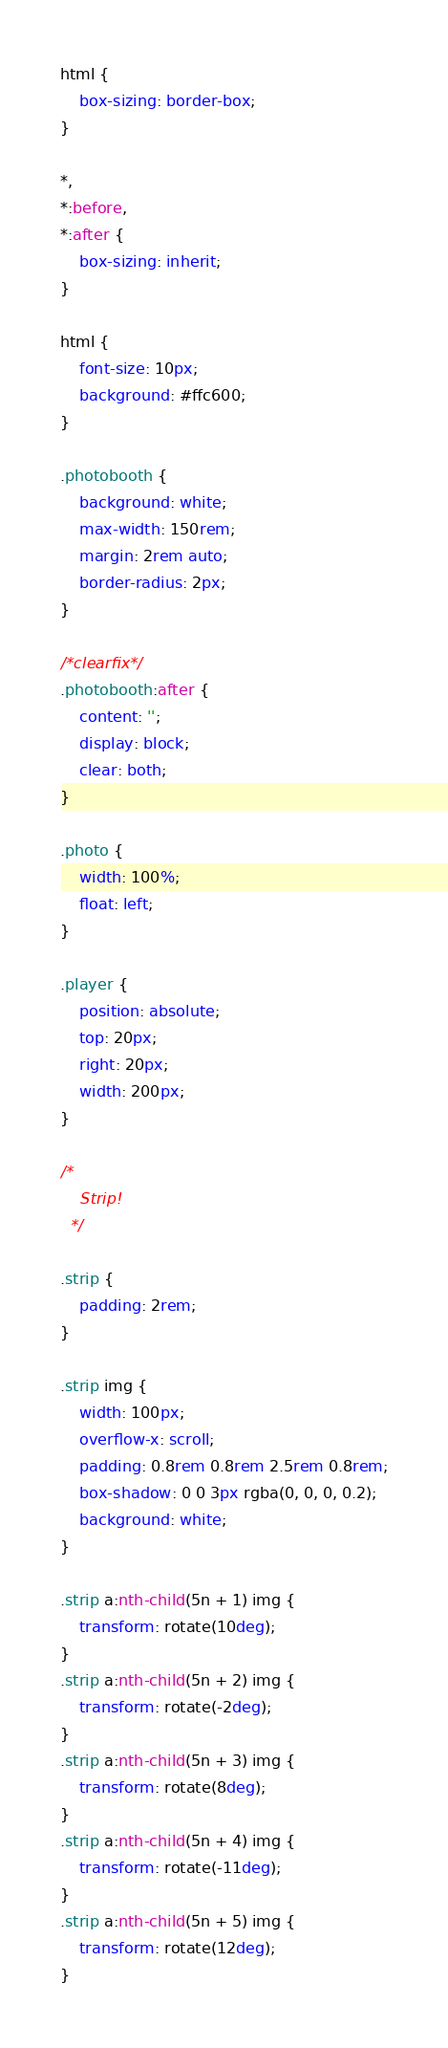<code> <loc_0><loc_0><loc_500><loc_500><_CSS_>html {
    box-sizing: border-box;
}

*,
*:before,
*:after {
    box-sizing: inherit;
}

html {
    font-size: 10px;
    background: #ffc600;
}

.photobooth {
    background: white;
    max-width: 150rem;
    margin: 2rem auto;
    border-radius: 2px;
}

/*clearfix*/
.photobooth:after {
    content: '';
    display: block;
    clear: both;
}

.photo {
    width: 100%;
    float: left;
}

.player {
    position: absolute;
    top: 20px;
    right: 20px;
    width: 200px;
}

/*
    Strip!
  */

.strip {
    padding: 2rem;
}

.strip img {
    width: 100px;
    overflow-x: scroll;
    padding: 0.8rem 0.8rem 2.5rem 0.8rem;
    box-shadow: 0 0 3px rgba(0, 0, 0, 0.2);
    background: white;
}

.strip a:nth-child(5n + 1) img {
    transform: rotate(10deg);
}
.strip a:nth-child(5n + 2) img {
    transform: rotate(-2deg);
}
.strip a:nth-child(5n + 3) img {
    transform: rotate(8deg);
}
.strip a:nth-child(5n + 4) img {
    transform: rotate(-11deg);
}
.strip a:nth-child(5n + 5) img {
    transform: rotate(12deg);
}
</code> 